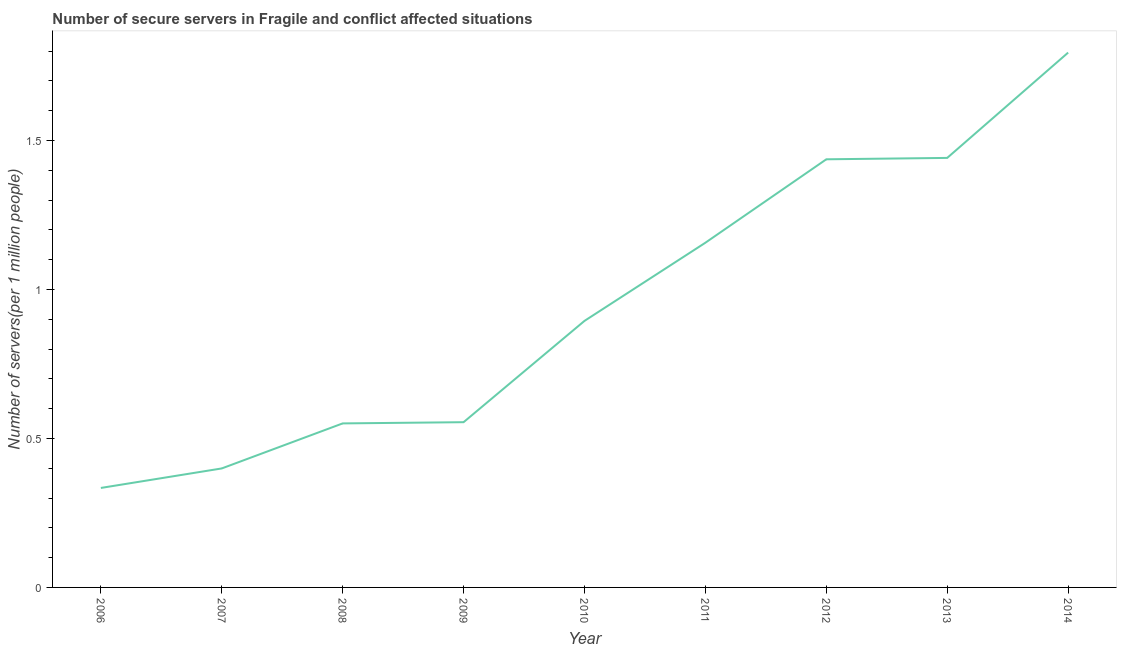What is the number of secure internet servers in 2012?
Give a very brief answer. 1.44. Across all years, what is the maximum number of secure internet servers?
Give a very brief answer. 1.8. Across all years, what is the minimum number of secure internet servers?
Make the answer very short. 0.33. In which year was the number of secure internet servers minimum?
Provide a short and direct response. 2006. What is the sum of the number of secure internet servers?
Your answer should be compact. 8.56. What is the difference between the number of secure internet servers in 2010 and 2013?
Give a very brief answer. -0.55. What is the average number of secure internet servers per year?
Ensure brevity in your answer.  0.95. What is the median number of secure internet servers?
Keep it short and to the point. 0.89. What is the ratio of the number of secure internet servers in 2008 to that in 2010?
Provide a short and direct response. 0.62. Is the number of secure internet servers in 2008 less than that in 2014?
Make the answer very short. Yes. What is the difference between the highest and the second highest number of secure internet servers?
Provide a short and direct response. 0.35. Is the sum of the number of secure internet servers in 2010 and 2014 greater than the maximum number of secure internet servers across all years?
Ensure brevity in your answer.  Yes. What is the difference between the highest and the lowest number of secure internet servers?
Give a very brief answer. 1.46. In how many years, is the number of secure internet servers greater than the average number of secure internet servers taken over all years?
Offer a very short reply. 4. Are the values on the major ticks of Y-axis written in scientific E-notation?
Provide a short and direct response. No. Does the graph contain any zero values?
Offer a terse response. No. What is the title of the graph?
Your answer should be compact. Number of secure servers in Fragile and conflict affected situations. What is the label or title of the X-axis?
Give a very brief answer. Year. What is the label or title of the Y-axis?
Make the answer very short. Number of servers(per 1 million people). What is the Number of servers(per 1 million people) of 2006?
Provide a succinct answer. 0.33. What is the Number of servers(per 1 million people) of 2007?
Provide a succinct answer. 0.4. What is the Number of servers(per 1 million people) in 2008?
Your answer should be very brief. 0.55. What is the Number of servers(per 1 million people) of 2009?
Provide a short and direct response. 0.55. What is the Number of servers(per 1 million people) in 2010?
Your answer should be compact. 0.89. What is the Number of servers(per 1 million people) in 2011?
Your response must be concise. 1.16. What is the Number of servers(per 1 million people) of 2012?
Provide a short and direct response. 1.44. What is the Number of servers(per 1 million people) in 2013?
Offer a terse response. 1.44. What is the Number of servers(per 1 million people) in 2014?
Your answer should be very brief. 1.8. What is the difference between the Number of servers(per 1 million people) in 2006 and 2007?
Offer a very short reply. -0.07. What is the difference between the Number of servers(per 1 million people) in 2006 and 2008?
Keep it short and to the point. -0.22. What is the difference between the Number of servers(per 1 million people) in 2006 and 2009?
Your answer should be compact. -0.22. What is the difference between the Number of servers(per 1 million people) in 2006 and 2010?
Keep it short and to the point. -0.56. What is the difference between the Number of servers(per 1 million people) in 2006 and 2011?
Provide a short and direct response. -0.82. What is the difference between the Number of servers(per 1 million people) in 2006 and 2012?
Offer a very short reply. -1.1. What is the difference between the Number of servers(per 1 million people) in 2006 and 2013?
Offer a very short reply. -1.11. What is the difference between the Number of servers(per 1 million people) in 2006 and 2014?
Your answer should be compact. -1.46. What is the difference between the Number of servers(per 1 million people) in 2007 and 2008?
Give a very brief answer. -0.15. What is the difference between the Number of servers(per 1 million people) in 2007 and 2009?
Ensure brevity in your answer.  -0.16. What is the difference between the Number of servers(per 1 million people) in 2007 and 2010?
Your response must be concise. -0.5. What is the difference between the Number of servers(per 1 million people) in 2007 and 2011?
Provide a short and direct response. -0.76. What is the difference between the Number of servers(per 1 million people) in 2007 and 2012?
Ensure brevity in your answer.  -1.04. What is the difference between the Number of servers(per 1 million people) in 2007 and 2013?
Provide a short and direct response. -1.04. What is the difference between the Number of servers(per 1 million people) in 2007 and 2014?
Offer a terse response. -1.4. What is the difference between the Number of servers(per 1 million people) in 2008 and 2009?
Keep it short and to the point. -0. What is the difference between the Number of servers(per 1 million people) in 2008 and 2010?
Ensure brevity in your answer.  -0.34. What is the difference between the Number of servers(per 1 million people) in 2008 and 2011?
Your response must be concise. -0.61. What is the difference between the Number of servers(per 1 million people) in 2008 and 2012?
Offer a terse response. -0.89. What is the difference between the Number of servers(per 1 million people) in 2008 and 2013?
Offer a terse response. -0.89. What is the difference between the Number of servers(per 1 million people) in 2008 and 2014?
Your answer should be compact. -1.24. What is the difference between the Number of servers(per 1 million people) in 2009 and 2010?
Ensure brevity in your answer.  -0.34. What is the difference between the Number of servers(per 1 million people) in 2009 and 2011?
Offer a terse response. -0.6. What is the difference between the Number of servers(per 1 million people) in 2009 and 2012?
Give a very brief answer. -0.88. What is the difference between the Number of servers(per 1 million people) in 2009 and 2013?
Provide a short and direct response. -0.89. What is the difference between the Number of servers(per 1 million people) in 2009 and 2014?
Make the answer very short. -1.24. What is the difference between the Number of servers(per 1 million people) in 2010 and 2011?
Give a very brief answer. -0.26. What is the difference between the Number of servers(per 1 million people) in 2010 and 2012?
Your answer should be very brief. -0.54. What is the difference between the Number of servers(per 1 million people) in 2010 and 2013?
Keep it short and to the point. -0.55. What is the difference between the Number of servers(per 1 million people) in 2010 and 2014?
Your answer should be very brief. -0.9. What is the difference between the Number of servers(per 1 million people) in 2011 and 2012?
Give a very brief answer. -0.28. What is the difference between the Number of servers(per 1 million people) in 2011 and 2013?
Provide a succinct answer. -0.28. What is the difference between the Number of servers(per 1 million people) in 2011 and 2014?
Give a very brief answer. -0.64. What is the difference between the Number of servers(per 1 million people) in 2012 and 2013?
Ensure brevity in your answer.  -0. What is the difference between the Number of servers(per 1 million people) in 2012 and 2014?
Provide a short and direct response. -0.36. What is the difference between the Number of servers(per 1 million people) in 2013 and 2014?
Keep it short and to the point. -0.35. What is the ratio of the Number of servers(per 1 million people) in 2006 to that in 2007?
Provide a short and direct response. 0.84. What is the ratio of the Number of servers(per 1 million people) in 2006 to that in 2008?
Your answer should be compact. 0.61. What is the ratio of the Number of servers(per 1 million people) in 2006 to that in 2009?
Keep it short and to the point. 0.6. What is the ratio of the Number of servers(per 1 million people) in 2006 to that in 2010?
Offer a very short reply. 0.37. What is the ratio of the Number of servers(per 1 million people) in 2006 to that in 2011?
Your answer should be very brief. 0.29. What is the ratio of the Number of servers(per 1 million people) in 2006 to that in 2012?
Ensure brevity in your answer.  0.23. What is the ratio of the Number of servers(per 1 million people) in 2006 to that in 2013?
Provide a succinct answer. 0.23. What is the ratio of the Number of servers(per 1 million people) in 2006 to that in 2014?
Your response must be concise. 0.19. What is the ratio of the Number of servers(per 1 million people) in 2007 to that in 2008?
Ensure brevity in your answer.  0.72. What is the ratio of the Number of servers(per 1 million people) in 2007 to that in 2009?
Give a very brief answer. 0.72. What is the ratio of the Number of servers(per 1 million people) in 2007 to that in 2010?
Provide a succinct answer. 0.45. What is the ratio of the Number of servers(per 1 million people) in 2007 to that in 2011?
Give a very brief answer. 0.34. What is the ratio of the Number of servers(per 1 million people) in 2007 to that in 2012?
Offer a very short reply. 0.28. What is the ratio of the Number of servers(per 1 million people) in 2007 to that in 2013?
Keep it short and to the point. 0.28. What is the ratio of the Number of servers(per 1 million people) in 2007 to that in 2014?
Your answer should be very brief. 0.22. What is the ratio of the Number of servers(per 1 million people) in 2008 to that in 2010?
Your answer should be compact. 0.61. What is the ratio of the Number of servers(per 1 million people) in 2008 to that in 2011?
Provide a short and direct response. 0.48. What is the ratio of the Number of servers(per 1 million people) in 2008 to that in 2012?
Your answer should be compact. 0.38. What is the ratio of the Number of servers(per 1 million people) in 2008 to that in 2013?
Ensure brevity in your answer.  0.38. What is the ratio of the Number of servers(per 1 million people) in 2008 to that in 2014?
Offer a very short reply. 0.31. What is the ratio of the Number of servers(per 1 million people) in 2009 to that in 2010?
Your response must be concise. 0.62. What is the ratio of the Number of servers(per 1 million people) in 2009 to that in 2011?
Provide a succinct answer. 0.48. What is the ratio of the Number of servers(per 1 million people) in 2009 to that in 2012?
Your answer should be compact. 0.39. What is the ratio of the Number of servers(per 1 million people) in 2009 to that in 2013?
Keep it short and to the point. 0.39. What is the ratio of the Number of servers(per 1 million people) in 2009 to that in 2014?
Provide a succinct answer. 0.31. What is the ratio of the Number of servers(per 1 million people) in 2010 to that in 2011?
Your answer should be compact. 0.77. What is the ratio of the Number of servers(per 1 million people) in 2010 to that in 2012?
Provide a succinct answer. 0.62. What is the ratio of the Number of servers(per 1 million people) in 2010 to that in 2013?
Offer a terse response. 0.62. What is the ratio of the Number of servers(per 1 million people) in 2010 to that in 2014?
Give a very brief answer. 0.5. What is the ratio of the Number of servers(per 1 million people) in 2011 to that in 2012?
Provide a succinct answer. 0.81. What is the ratio of the Number of servers(per 1 million people) in 2011 to that in 2013?
Give a very brief answer. 0.8. What is the ratio of the Number of servers(per 1 million people) in 2011 to that in 2014?
Give a very brief answer. 0.65. What is the ratio of the Number of servers(per 1 million people) in 2012 to that in 2014?
Provide a short and direct response. 0.8. What is the ratio of the Number of servers(per 1 million people) in 2013 to that in 2014?
Make the answer very short. 0.8. 